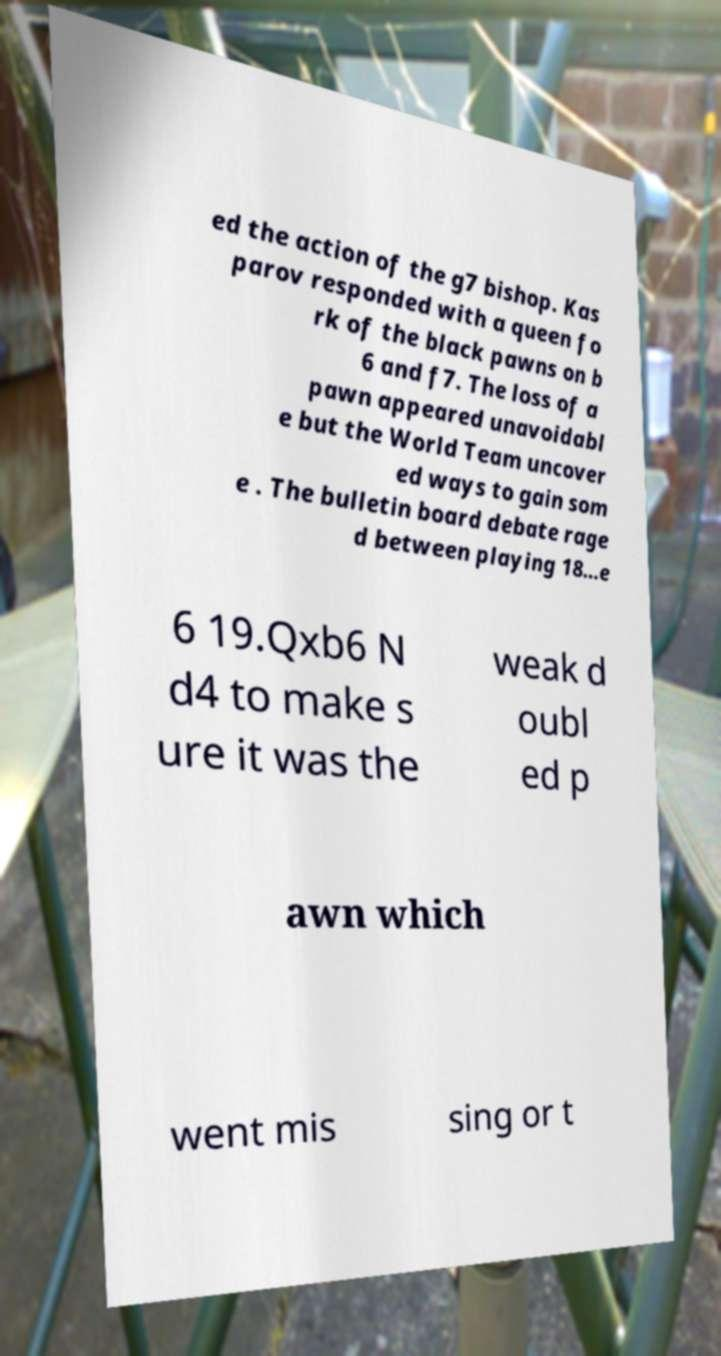I need the written content from this picture converted into text. Can you do that? ed the action of the g7 bishop. Kas parov responded with a queen fo rk of the black pawns on b 6 and f7. The loss of a pawn appeared unavoidabl e but the World Team uncover ed ways to gain som e . The bulletin board debate rage d between playing 18...e 6 19.Qxb6 N d4 to make s ure it was the weak d oubl ed p awn which went mis sing or t 